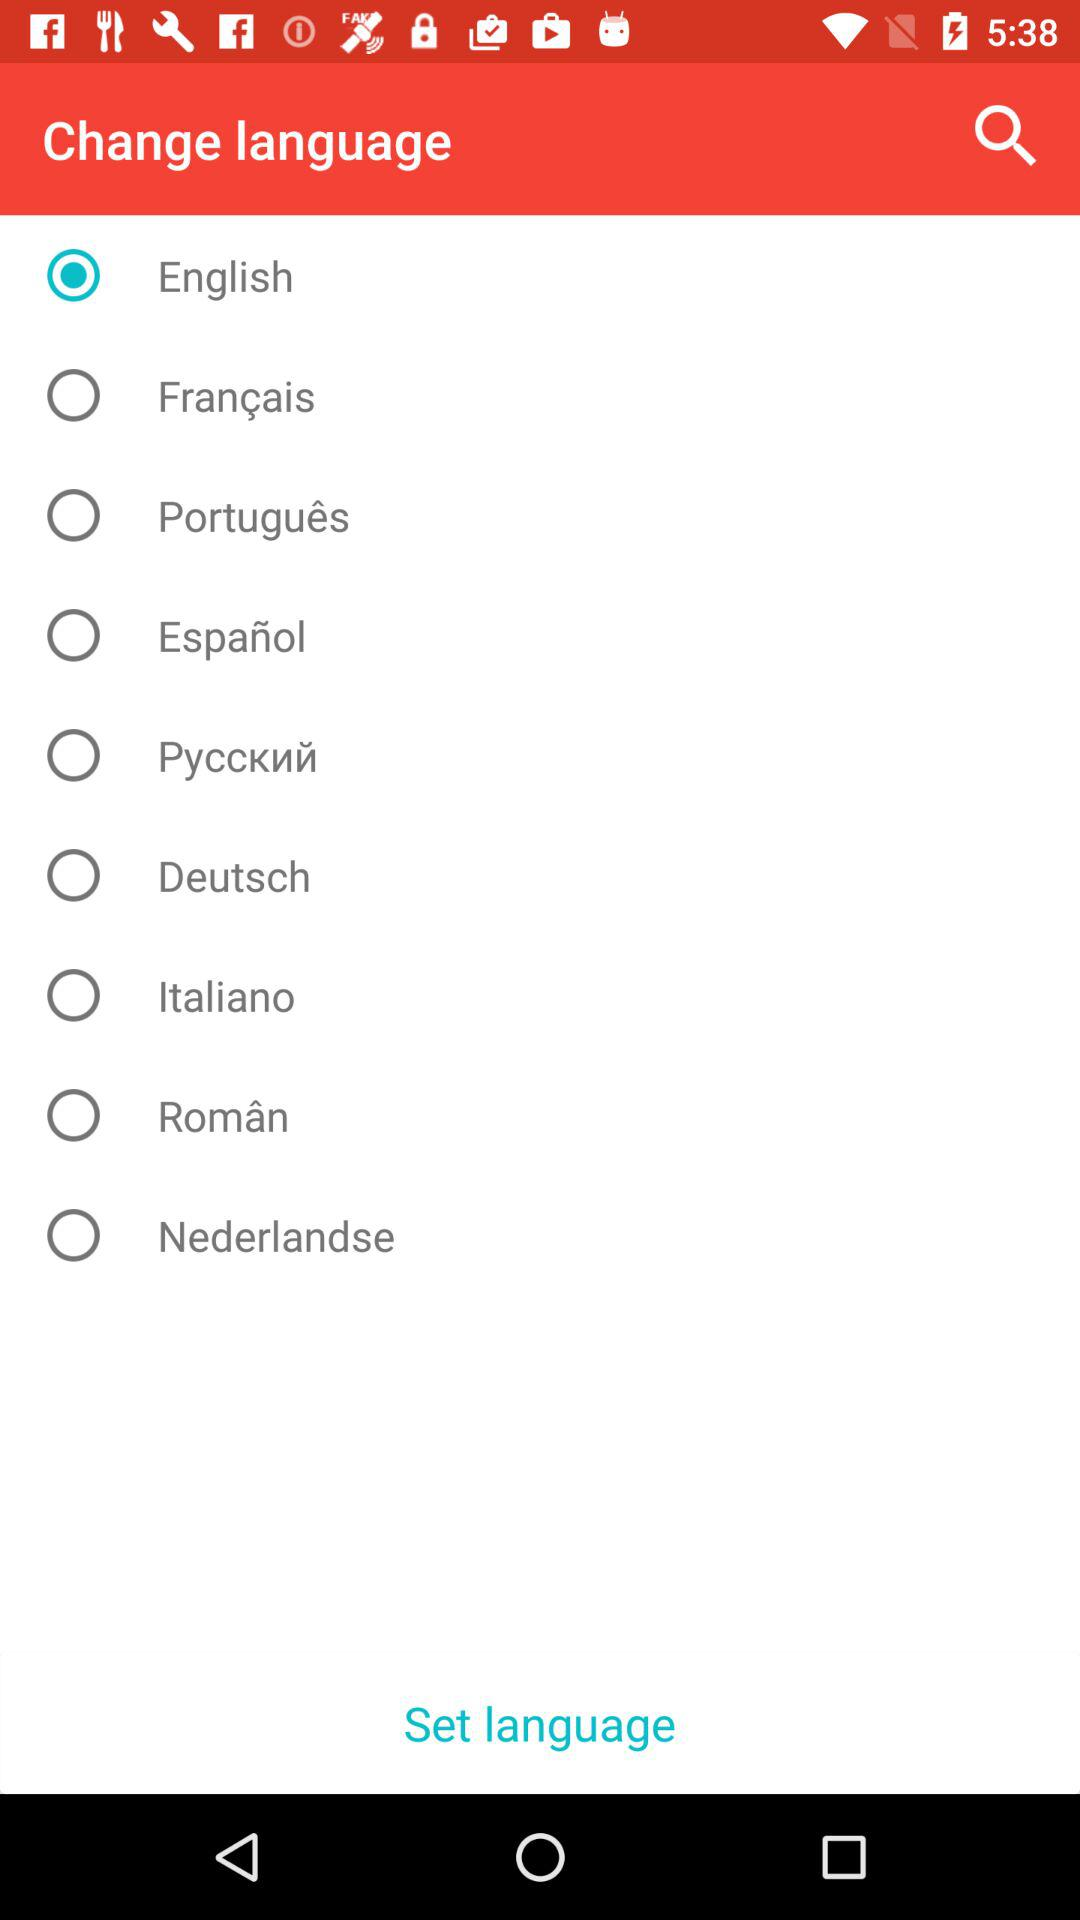How many languages are available in the language selection menu?
Answer the question using a single word or phrase. 9 